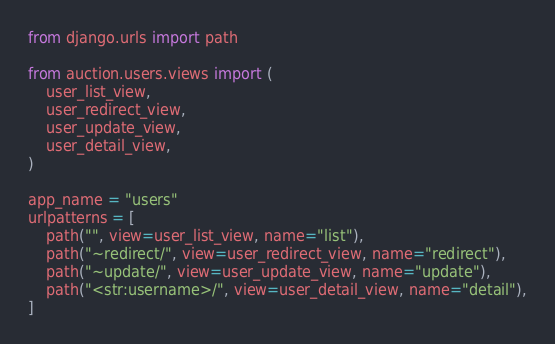<code> <loc_0><loc_0><loc_500><loc_500><_Python_>from django.urls import path

from auction.users.views import (
    user_list_view,
    user_redirect_view,
    user_update_view,
    user_detail_view,
)

app_name = "users"
urlpatterns = [
    path("", view=user_list_view, name="list"),
    path("~redirect/", view=user_redirect_view, name="redirect"),
    path("~update/", view=user_update_view, name="update"),
    path("<str:username>/", view=user_detail_view, name="detail"),
]
</code> 